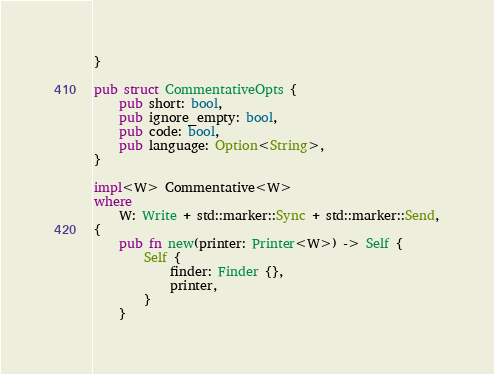<code> <loc_0><loc_0><loc_500><loc_500><_Rust_>}

pub struct CommentativeOpts {
    pub short: bool,
    pub ignore_empty: bool,
    pub code: bool,
    pub language: Option<String>,
}

impl<W> Commentative<W>
where
    W: Write + std::marker::Sync + std::marker::Send,
{
    pub fn new(printer: Printer<W>) -> Self {
        Self {
            finder: Finder {},
            printer,
        }
    }
</code> 